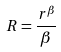<formula> <loc_0><loc_0><loc_500><loc_500>R = \frac { r ^ { \beta } } { \beta }</formula> 